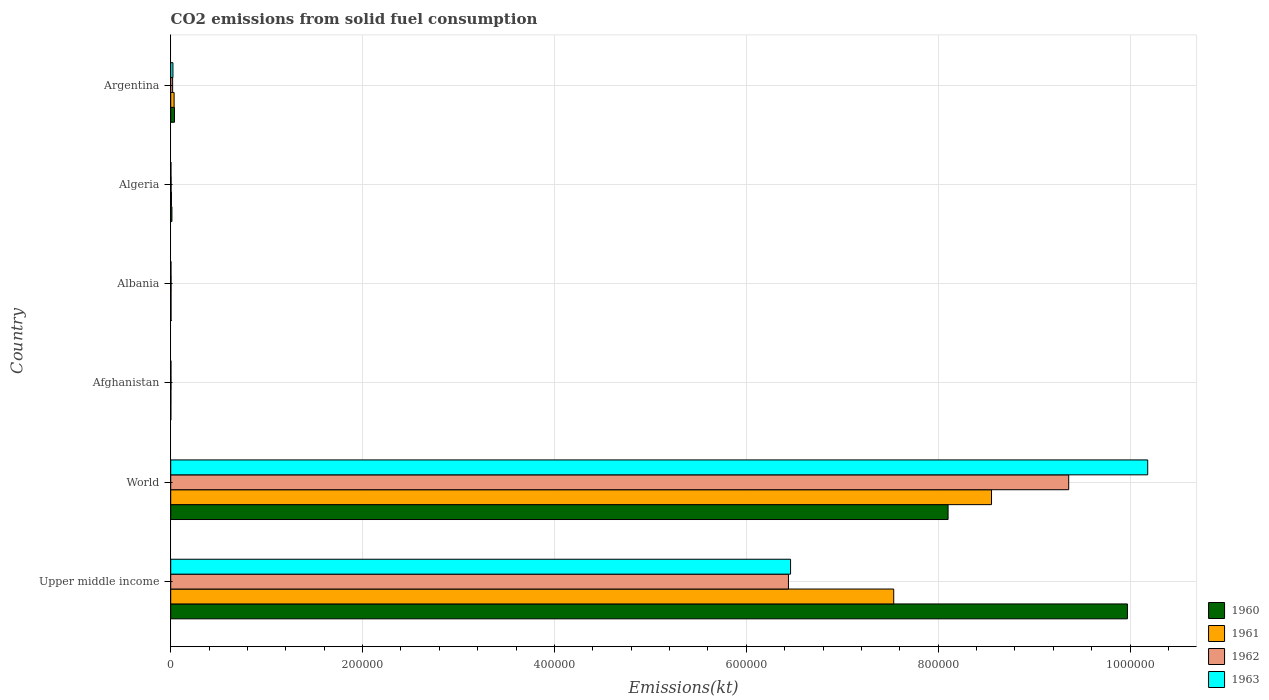How many different coloured bars are there?
Keep it short and to the point. 4. Are the number of bars per tick equal to the number of legend labels?
Keep it short and to the point. Yes. Are the number of bars on each tick of the Y-axis equal?
Provide a short and direct response. Yes. What is the label of the 5th group of bars from the top?
Offer a very short reply. World. What is the amount of CO2 emitted in 1961 in Upper middle income?
Your response must be concise. 7.54e+05. Across all countries, what is the maximum amount of CO2 emitted in 1961?
Your response must be concise. 8.56e+05. Across all countries, what is the minimum amount of CO2 emitted in 1961?
Offer a terse response. 176.02. In which country was the amount of CO2 emitted in 1963 maximum?
Keep it short and to the point. World. In which country was the amount of CO2 emitted in 1960 minimum?
Provide a short and direct response. Afghanistan. What is the total amount of CO2 emitted in 1962 in the graph?
Make the answer very short. 1.58e+06. What is the difference between the amount of CO2 emitted in 1963 in Algeria and that in World?
Keep it short and to the point. -1.02e+06. What is the difference between the amount of CO2 emitted in 1962 in Argentina and the amount of CO2 emitted in 1961 in World?
Offer a very short reply. -8.54e+05. What is the average amount of CO2 emitted in 1962 per country?
Give a very brief answer. 2.64e+05. What is the difference between the amount of CO2 emitted in 1960 and amount of CO2 emitted in 1961 in Afghanistan?
Ensure brevity in your answer.  -47.67. In how many countries, is the amount of CO2 emitted in 1962 greater than 560000 kt?
Give a very brief answer. 2. What is the ratio of the amount of CO2 emitted in 1960 in Afghanistan to that in Upper middle income?
Keep it short and to the point. 0. Is the difference between the amount of CO2 emitted in 1960 in Afghanistan and Algeria greater than the difference between the amount of CO2 emitted in 1961 in Afghanistan and Algeria?
Give a very brief answer. No. What is the difference between the highest and the second highest amount of CO2 emitted in 1963?
Give a very brief answer. 3.72e+05. What is the difference between the highest and the lowest amount of CO2 emitted in 1961?
Your answer should be very brief. 8.55e+05. Is it the case that in every country, the sum of the amount of CO2 emitted in 1962 and amount of CO2 emitted in 1963 is greater than the sum of amount of CO2 emitted in 1961 and amount of CO2 emitted in 1960?
Give a very brief answer. No. What does the 3rd bar from the top in Algeria represents?
Keep it short and to the point. 1961. Is it the case that in every country, the sum of the amount of CO2 emitted in 1963 and amount of CO2 emitted in 1960 is greater than the amount of CO2 emitted in 1962?
Offer a very short reply. Yes. How many bars are there?
Your answer should be compact. 24. Are the values on the major ticks of X-axis written in scientific E-notation?
Your answer should be very brief. No. Does the graph contain grids?
Provide a short and direct response. Yes. Where does the legend appear in the graph?
Give a very brief answer. Bottom right. How many legend labels are there?
Provide a succinct answer. 4. How are the legend labels stacked?
Offer a terse response. Vertical. What is the title of the graph?
Make the answer very short. CO2 emissions from solid fuel consumption. What is the label or title of the X-axis?
Offer a very short reply. Emissions(kt). What is the Emissions(kt) in 1960 in Upper middle income?
Ensure brevity in your answer.  9.97e+05. What is the Emissions(kt) of 1961 in Upper middle income?
Make the answer very short. 7.54e+05. What is the Emissions(kt) of 1962 in Upper middle income?
Keep it short and to the point. 6.44e+05. What is the Emissions(kt) of 1963 in Upper middle income?
Provide a succinct answer. 6.46e+05. What is the Emissions(kt) in 1960 in World?
Give a very brief answer. 8.10e+05. What is the Emissions(kt) of 1961 in World?
Provide a short and direct response. 8.56e+05. What is the Emissions(kt) of 1962 in World?
Provide a succinct answer. 9.36e+05. What is the Emissions(kt) of 1963 in World?
Provide a succinct answer. 1.02e+06. What is the Emissions(kt) in 1960 in Afghanistan?
Your answer should be compact. 128.34. What is the Emissions(kt) in 1961 in Afghanistan?
Your answer should be very brief. 176.02. What is the Emissions(kt) in 1962 in Afghanistan?
Keep it short and to the point. 297.03. What is the Emissions(kt) of 1963 in Afghanistan?
Keep it short and to the point. 264.02. What is the Emissions(kt) of 1960 in Albania?
Ensure brevity in your answer.  326.36. What is the Emissions(kt) of 1961 in Albania?
Keep it short and to the point. 322.7. What is the Emissions(kt) in 1962 in Albania?
Offer a terse response. 363.03. What is the Emissions(kt) of 1963 in Albania?
Give a very brief answer. 282.36. What is the Emissions(kt) of 1960 in Algeria?
Provide a short and direct response. 1257.78. What is the Emissions(kt) in 1961 in Algeria?
Ensure brevity in your answer.  766.4. What is the Emissions(kt) in 1962 in Algeria?
Offer a very short reply. 407.04. What is the Emissions(kt) of 1963 in Algeria?
Offer a very short reply. 253.02. What is the Emissions(kt) in 1960 in Argentina?
Your answer should be very brief. 3909.02. What is the Emissions(kt) of 1961 in Argentina?
Offer a very short reply. 3542.32. What is the Emissions(kt) in 1962 in Argentina?
Keep it short and to the point. 2009.52. What is the Emissions(kt) in 1963 in Argentina?
Your answer should be very brief. 2306.54. Across all countries, what is the maximum Emissions(kt) of 1960?
Provide a succinct answer. 9.97e+05. Across all countries, what is the maximum Emissions(kt) of 1961?
Provide a short and direct response. 8.56e+05. Across all countries, what is the maximum Emissions(kt) in 1962?
Give a very brief answer. 9.36e+05. Across all countries, what is the maximum Emissions(kt) in 1963?
Give a very brief answer. 1.02e+06. Across all countries, what is the minimum Emissions(kt) of 1960?
Offer a terse response. 128.34. Across all countries, what is the minimum Emissions(kt) of 1961?
Give a very brief answer. 176.02. Across all countries, what is the minimum Emissions(kt) in 1962?
Make the answer very short. 297.03. Across all countries, what is the minimum Emissions(kt) in 1963?
Ensure brevity in your answer.  253.02. What is the total Emissions(kt) of 1960 in the graph?
Give a very brief answer. 1.81e+06. What is the total Emissions(kt) in 1961 in the graph?
Provide a succinct answer. 1.61e+06. What is the total Emissions(kt) in 1962 in the graph?
Keep it short and to the point. 1.58e+06. What is the total Emissions(kt) in 1963 in the graph?
Make the answer very short. 1.67e+06. What is the difference between the Emissions(kt) of 1960 in Upper middle income and that in World?
Your answer should be compact. 1.87e+05. What is the difference between the Emissions(kt) of 1961 in Upper middle income and that in World?
Make the answer very short. -1.02e+05. What is the difference between the Emissions(kt) of 1962 in Upper middle income and that in World?
Offer a very short reply. -2.92e+05. What is the difference between the Emissions(kt) in 1963 in Upper middle income and that in World?
Provide a short and direct response. -3.72e+05. What is the difference between the Emissions(kt) of 1960 in Upper middle income and that in Afghanistan?
Keep it short and to the point. 9.97e+05. What is the difference between the Emissions(kt) of 1961 in Upper middle income and that in Afghanistan?
Give a very brief answer. 7.53e+05. What is the difference between the Emissions(kt) in 1962 in Upper middle income and that in Afghanistan?
Your answer should be compact. 6.44e+05. What is the difference between the Emissions(kt) of 1963 in Upper middle income and that in Afghanistan?
Offer a very short reply. 6.46e+05. What is the difference between the Emissions(kt) in 1960 in Upper middle income and that in Albania?
Your answer should be very brief. 9.97e+05. What is the difference between the Emissions(kt) of 1961 in Upper middle income and that in Albania?
Offer a very short reply. 7.53e+05. What is the difference between the Emissions(kt) in 1962 in Upper middle income and that in Albania?
Give a very brief answer. 6.44e+05. What is the difference between the Emissions(kt) in 1963 in Upper middle income and that in Albania?
Your answer should be compact. 6.46e+05. What is the difference between the Emissions(kt) in 1960 in Upper middle income and that in Algeria?
Keep it short and to the point. 9.96e+05. What is the difference between the Emissions(kt) in 1961 in Upper middle income and that in Algeria?
Make the answer very short. 7.53e+05. What is the difference between the Emissions(kt) of 1962 in Upper middle income and that in Algeria?
Provide a succinct answer. 6.44e+05. What is the difference between the Emissions(kt) in 1963 in Upper middle income and that in Algeria?
Your answer should be compact. 6.46e+05. What is the difference between the Emissions(kt) of 1960 in Upper middle income and that in Argentina?
Your answer should be very brief. 9.93e+05. What is the difference between the Emissions(kt) in 1961 in Upper middle income and that in Argentina?
Make the answer very short. 7.50e+05. What is the difference between the Emissions(kt) of 1962 in Upper middle income and that in Argentina?
Your answer should be very brief. 6.42e+05. What is the difference between the Emissions(kt) in 1963 in Upper middle income and that in Argentina?
Make the answer very short. 6.44e+05. What is the difference between the Emissions(kt) in 1960 in World and that in Afghanistan?
Offer a very short reply. 8.10e+05. What is the difference between the Emissions(kt) of 1961 in World and that in Afghanistan?
Your response must be concise. 8.55e+05. What is the difference between the Emissions(kt) in 1962 in World and that in Afghanistan?
Your answer should be compact. 9.36e+05. What is the difference between the Emissions(kt) of 1963 in World and that in Afghanistan?
Provide a short and direct response. 1.02e+06. What is the difference between the Emissions(kt) in 1960 in World and that in Albania?
Keep it short and to the point. 8.10e+05. What is the difference between the Emissions(kt) of 1961 in World and that in Albania?
Keep it short and to the point. 8.55e+05. What is the difference between the Emissions(kt) in 1962 in World and that in Albania?
Your answer should be compact. 9.36e+05. What is the difference between the Emissions(kt) in 1963 in World and that in Albania?
Keep it short and to the point. 1.02e+06. What is the difference between the Emissions(kt) in 1960 in World and that in Algeria?
Provide a short and direct response. 8.09e+05. What is the difference between the Emissions(kt) of 1961 in World and that in Algeria?
Your answer should be compact. 8.55e+05. What is the difference between the Emissions(kt) of 1962 in World and that in Algeria?
Your answer should be compact. 9.36e+05. What is the difference between the Emissions(kt) of 1963 in World and that in Algeria?
Provide a succinct answer. 1.02e+06. What is the difference between the Emissions(kt) of 1960 in World and that in Argentina?
Provide a short and direct response. 8.06e+05. What is the difference between the Emissions(kt) in 1961 in World and that in Argentina?
Provide a short and direct response. 8.52e+05. What is the difference between the Emissions(kt) of 1962 in World and that in Argentina?
Your answer should be compact. 9.34e+05. What is the difference between the Emissions(kt) in 1963 in World and that in Argentina?
Keep it short and to the point. 1.02e+06. What is the difference between the Emissions(kt) in 1960 in Afghanistan and that in Albania?
Ensure brevity in your answer.  -198.02. What is the difference between the Emissions(kt) of 1961 in Afghanistan and that in Albania?
Offer a terse response. -146.68. What is the difference between the Emissions(kt) of 1962 in Afghanistan and that in Albania?
Offer a very short reply. -66.01. What is the difference between the Emissions(kt) in 1963 in Afghanistan and that in Albania?
Provide a short and direct response. -18.34. What is the difference between the Emissions(kt) in 1960 in Afghanistan and that in Algeria?
Provide a short and direct response. -1129.44. What is the difference between the Emissions(kt) of 1961 in Afghanistan and that in Algeria?
Make the answer very short. -590.39. What is the difference between the Emissions(kt) in 1962 in Afghanistan and that in Algeria?
Your answer should be very brief. -110.01. What is the difference between the Emissions(kt) of 1963 in Afghanistan and that in Algeria?
Make the answer very short. 11. What is the difference between the Emissions(kt) of 1960 in Afghanistan and that in Argentina?
Give a very brief answer. -3780.68. What is the difference between the Emissions(kt) in 1961 in Afghanistan and that in Argentina?
Make the answer very short. -3366.31. What is the difference between the Emissions(kt) in 1962 in Afghanistan and that in Argentina?
Provide a succinct answer. -1712.49. What is the difference between the Emissions(kt) of 1963 in Afghanistan and that in Argentina?
Provide a succinct answer. -2042.52. What is the difference between the Emissions(kt) of 1960 in Albania and that in Algeria?
Your answer should be very brief. -931.42. What is the difference between the Emissions(kt) in 1961 in Albania and that in Algeria?
Your answer should be very brief. -443.71. What is the difference between the Emissions(kt) of 1962 in Albania and that in Algeria?
Ensure brevity in your answer.  -44. What is the difference between the Emissions(kt) of 1963 in Albania and that in Algeria?
Offer a terse response. 29.34. What is the difference between the Emissions(kt) in 1960 in Albania and that in Argentina?
Give a very brief answer. -3582.66. What is the difference between the Emissions(kt) in 1961 in Albania and that in Argentina?
Make the answer very short. -3219.63. What is the difference between the Emissions(kt) of 1962 in Albania and that in Argentina?
Keep it short and to the point. -1646.48. What is the difference between the Emissions(kt) of 1963 in Albania and that in Argentina?
Provide a succinct answer. -2024.18. What is the difference between the Emissions(kt) in 1960 in Algeria and that in Argentina?
Ensure brevity in your answer.  -2651.24. What is the difference between the Emissions(kt) in 1961 in Algeria and that in Argentina?
Offer a terse response. -2775.92. What is the difference between the Emissions(kt) of 1962 in Algeria and that in Argentina?
Give a very brief answer. -1602.48. What is the difference between the Emissions(kt) in 1963 in Algeria and that in Argentina?
Your answer should be compact. -2053.52. What is the difference between the Emissions(kt) of 1960 in Upper middle income and the Emissions(kt) of 1961 in World?
Offer a very short reply. 1.42e+05. What is the difference between the Emissions(kt) in 1960 in Upper middle income and the Emissions(kt) in 1962 in World?
Offer a very short reply. 6.12e+04. What is the difference between the Emissions(kt) of 1960 in Upper middle income and the Emissions(kt) of 1963 in World?
Ensure brevity in your answer.  -2.12e+04. What is the difference between the Emissions(kt) of 1961 in Upper middle income and the Emissions(kt) of 1962 in World?
Keep it short and to the point. -1.82e+05. What is the difference between the Emissions(kt) in 1961 in Upper middle income and the Emissions(kt) in 1963 in World?
Your response must be concise. -2.65e+05. What is the difference between the Emissions(kt) of 1962 in Upper middle income and the Emissions(kt) of 1963 in World?
Ensure brevity in your answer.  -3.74e+05. What is the difference between the Emissions(kt) of 1960 in Upper middle income and the Emissions(kt) of 1961 in Afghanistan?
Your response must be concise. 9.97e+05. What is the difference between the Emissions(kt) of 1960 in Upper middle income and the Emissions(kt) of 1962 in Afghanistan?
Your response must be concise. 9.97e+05. What is the difference between the Emissions(kt) of 1960 in Upper middle income and the Emissions(kt) of 1963 in Afghanistan?
Provide a succinct answer. 9.97e+05. What is the difference between the Emissions(kt) in 1961 in Upper middle income and the Emissions(kt) in 1962 in Afghanistan?
Ensure brevity in your answer.  7.53e+05. What is the difference between the Emissions(kt) of 1961 in Upper middle income and the Emissions(kt) of 1963 in Afghanistan?
Your response must be concise. 7.53e+05. What is the difference between the Emissions(kt) in 1962 in Upper middle income and the Emissions(kt) in 1963 in Afghanistan?
Offer a terse response. 6.44e+05. What is the difference between the Emissions(kt) in 1960 in Upper middle income and the Emissions(kt) in 1961 in Albania?
Your answer should be very brief. 9.97e+05. What is the difference between the Emissions(kt) in 1960 in Upper middle income and the Emissions(kt) in 1962 in Albania?
Give a very brief answer. 9.97e+05. What is the difference between the Emissions(kt) in 1960 in Upper middle income and the Emissions(kt) in 1963 in Albania?
Give a very brief answer. 9.97e+05. What is the difference between the Emissions(kt) in 1961 in Upper middle income and the Emissions(kt) in 1962 in Albania?
Your answer should be very brief. 7.53e+05. What is the difference between the Emissions(kt) in 1961 in Upper middle income and the Emissions(kt) in 1963 in Albania?
Ensure brevity in your answer.  7.53e+05. What is the difference between the Emissions(kt) of 1962 in Upper middle income and the Emissions(kt) of 1963 in Albania?
Offer a very short reply. 6.44e+05. What is the difference between the Emissions(kt) of 1960 in Upper middle income and the Emissions(kt) of 1961 in Algeria?
Offer a terse response. 9.97e+05. What is the difference between the Emissions(kt) of 1960 in Upper middle income and the Emissions(kt) of 1962 in Algeria?
Offer a terse response. 9.97e+05. What is the difference between the Emissions(kt) of 1960 in Upper middle income and the Emissions(kt) of 1963 in Algeria?
Offer a very short reply. 9.97e+05. What is the difference between the Emissions(kt) in 1961 in Upper middle income and the Emissions(kt) in 1962 in Algeria?
Keep it short and to the point. 7.53e+05. What is the difference between the Emissions(kt) in 1961 in Upper middle income and the Emissions(kt) in 1963 in Algeria?
Give a very brief answer. 7.53e+05. What is the difference between the Emissions(kt) in 1962 in Upper middle income and the Emissions(kt) in 1963 in Algeria?
Keep it short and to the point. 6.44e+05. What is the difference between the Emissions(kt) in 1960 in Upper middle income and the Emissions(kt) in 1961 in Argentina?
Make the answer very short. 9.94e+05. What is the difference between the Emissions(kt) of 1960 in Upper middle income and the Emissions(kt) of 1962 in Argentina?
Give a very brief answer. 9.95e+05. What is the difference between the Emissions(kt) of 1960 in Upper middle income and the Emissions(kt) of 1963 in Argentina?
Ensure brevity in your answer.  9.95e+05. What is the difference between the Emissions(kt) in 1961 in Upper middle income and the Emissions(kt) in 1962 in Argentina?
Keep it short and to the point. 7.52e+05. What is the difference between the Emissions(kt) in 1961 in Upper middle income and the Emissions(kt) in 1963 in Argentina?
Ensure brevity in your answer.  7.51e+05. What is the difference between the Emissions(kt) in 1962 in Upper middle income and the Emissions(kt) in 1963 in Argentina?
Provide a short and direct response. 6.42e+05. What is the difference between the Emissions(kt) of 1960 in World and the Emissions(kt) of 1961 in Afghanistan?
Ensure brevity in your answer.  8.10e+05. What is the difference between the Emissions(kt) of 1960 in World and the Emissions(kt) of 1962 in Afghanistan?
Give a very brief answer. 8.10e+05. What is the difference between the Emissions(kt) in 1960 in World and the Emissions(kt) in 1963 in Afghanistan?
Ensure brevity in your answer.  8.10e+05. What is the difference between the Emissions(kt) in 1961 in World and the Emissions(kt) in 1962 in Afghanistan?
Offer a very short reply. 8.55e+05. What is the difference between the Emissions(kt) in 1961 in World and the Emissions(kt) in 1963 in Afghanistan?
Your answer should be very brief. 8.55e+05. What is the difference between the Emissions(kt) in 1962 in World and the Emissions(kt) in 1963 in Afghanistan?
Your answer should be very brief. 9.36e+05. What is the difference between the Emissions(kt) in 1960 in World and the Emissions(kt) in 1961 in Albania?
Ensure brevity in your answer.  8.10e+05. What is the difference between the Emissions(kt) of 1960 in World and the Emissions(kt) of 1962 in Albania?
Provide a short and direct response. 8.10e+05. What is the difference between the Emissions(kt) of 1960 in World and the Emissions(kt) of 1963 in Albania?
Provide a succinct answer. 8.10e+05. What is the difference between the Emissions(kt) of 1961 in World and the Emissions(kt) of 1962 in Albania?
Give a very brief answer. 8.55e+05. What is the difference between the Emissions(kt) of 1961 in World and the Emissions(kt) of 1963 in Albania?
Ensure brevity in your answer.  8.55e+05. What is the difference between the Emissions(kt) of 1962 in World and the Emissions(kt) of 1963 in Albania?
Ensure brevity in your answer.  9.36e+05. What is the difference between the Emissions(kt) in 1960 in World and the Emissions(kt) in 1961 in Algeria?
Give a very brief answer. 8.10e+05. What is the difference between the Emissions(kt) in 1960 in World and the Emissions(kt) in 1962 in Algeria?
Keep it short and to the point. 8.10e+05. What is the difference between the Emissions(kt) in 1960 in World and the Emissions(kt) in 1963 in Algeria?
Your answer should be very brief. 8.10e+05. What is the difference between the Emissions(kt) of 1961 in World and the Emissions(kt) of 1962 in Algeria?
Your response must be concise. 8.55e+05. What is the difference between the Emissions(kt) in 1961 in World and the Emissions(kt) in 1963 in Algeria?
Give a very brief answer. 8.55e+05. What is the difference between the Emissions(kt) of 1962 in World and the Emissions(kt) of 1963 in Algeria?
Ensure brevity in your answer.  9.36e+05. What is the difference between the Emissions(kt) of 1960 in World and the Emissions(kt) of 1961 in Argentina?
Offer a terse response. 8.07e+05. What is the difference between the Emissions(kt) in 1960 in World and the Emissions(kt) in 1962 in Argentina?
Offer a very short reply. 8.08e+05. What is the difference between the Emissions(kt) in 1960 in World and the Emissions(kt) in 1963 in Argentina?
Your answer should be compact. 8.08e+05. What is the difference between the Emissions(kt) of 1961 in World and the Emissions(kt) of 1962 in Argentina?
Provide a short and direct response. 8.54e+05. What is the difference between the Emissions(kt) of 1961 in World and the Emissions(kt) of 1963 in Argentina?
Your response must be concise. 8.53e+05. What is the difference between the Emissions(kt) of 1962 in World and the Emissions(kt) of 1963 in Argentina?
Give a very brief answer. 9.34e+05. What is the difference between the Emissions(kt) in 1960 in Afghanistan and the Emissions(kt) in 1961 in Albania?
Ensure brevity in your answer.  -194.35. What is the difference between the Emissions(kt) in 1960 in Afghanistan and the Emissions(kt) in 1962 in Albania?
Make the answer very short. -234.69. What is the difference between the Emissions(kt) of 1960 in Afghanistan and the Emissions(kt) of 1963 in Albania?
Offer a terse response. -154.01. What is the difference between the Emissions(kt) of 1961 in Afghanistan and the Emissions(kt) of 1962 in Albania?
Keep it short and to the point. -187.02. What is the difference between the Emissions(kt) in 1961 in Afghanistan and the Emissions(kt) in 1963 in Albania?
Your answer should be very brief. -106.34. What is the difference between the Emissions(kt) of 1962 in Afghanistan and the Emissions(kt) of 1963 in Albania?
Offer a terse response. 14.67. What is the difference between the Emissions(kt) of 1960 in Afghanistan and the Emissions(kt) of 1961 in Algeria?
Your answer should be very brief. -638.06. What is the difference between the Emissions(kt) of 1960 in Afghanistan and the Emissions(kt) of 1962 in Algeria?
Your answer should be very brief. -278.69. What is the difference between the Emissions(kt) of 1960 in Afghanistan and the Emissions(kt) of 1963 in Algeria?
Offer a very short reply. -124.68. What is the difference between the Emissions(kt) of 1961 in Afghanistan and the Emissions(kt) of 1962 in Algeria?
Ensure brevity in your answer.  -231.02. What is the difference between the Emissions(kt) in 1961 in Afghanistan and the Emissions(kt) in 1963 in Algeria?
Your answer should be compact. -77.01. What is the difference between the Emissions(kt) in 1962 in Afghanistan and the Emissions(kt) in 1963 in Algeria?
Keep it short and to the point. 44. What is the difference between the Emissions(kt) in 1960 in Afghanistan and the Emissions(kt) in 1961 in Argentina?
Your answer should be compact. -3413.98. What is the difference between the Emissions(kt) of 1960 in Afghanistan and the Emissions(kt) of 1962 in Argentina?
Provide a succinct answer. -1881.17. What is the difference between the Emissions(kt) of 1960 in Afghanistan and the Emissions(kt) of 1963 in Argentina?
Offer a terse response. -2178.2. What is the difference between the Emissions(kt) in 1961 in Afghanistan and the Emissions(kt) in 1962 in Argentina?
Your answer should be very brief. -1833.5. What is the difference between the Emissions(kt) in 1961 in Afghanistan and the Emissions(kt) in 1963 in Argentina?
Your response must be concise. -2130.53. What is the difference between the Emissions(kt) in 1962 in Afghanistan and the Emissions(kt) in 1963 in Argentina?
Keep it short and to the point. -2009.52. What is the difference between the Emissions(kt) of 1960 in Albania and the Emissions(kt) of 1961 in Algeria?
Offer a very short reply. -440.04. What is the difference between the Emissions(kt) in 1960 in Albania and the Emissions(kt) in 1962 in Algeria?
Your answer should be very brief. -80.67. What is the difference between the Emissions(kt) of 1960 in Albania and the Emissions(kt) of 1963 in Algeria?
Offer a very short reply. 73.34. What is the difference between the Emissions(kt) of 1961 in Albania and the Emissions(kt) of 1962 in Algeria?
Your response must be concise. -84.34. What is the difference between the Emissions(kt) of 1961 in Albania and the Emissions(kt) of 1963 in Algeria?
Ensure brevity in your answer.  69.67. What is the difference between the Emissions(kt) in 1962 in Albania and the Emissions(kt) in 1963 in Algeria?
Offer a very short reply. 110.01. What is the difference between the Emissions(kt) in 1960 in Albania and the Emissions(kt) in 1961 in Argentina?
Make the answer very short. -3215.96. What is the difference between the Emissions(kt) in 1960 in Albania and the Emissions(kt) in 1962 in Argentina?
Ensure brevity in your answer.  -1683.15. What is the difference between the Emissions(kt) of 1960 in Albania and the Emissions(kt) of 1963 in Argentina?
Offer a terse response. -1980.18. What is the difference between the Emissions(kt) of 1961 in Albania and the Emissions(kt) of 1962 in Argentina?
Provide a succinct answer. -1686.82. What is the difference between the Emissions(kt) of 1961 in Albania and the Emissions(kt) of 1963 in Argentina?
Keep it short and to the point. -1983.85. What is the difference between the Emissions(kt) in 1962 in Albania and the Emissions(kt) in 1963 in Argentina?
Your answer should be compact. -1943.51. What is the difference between the Emissions(kt) in 1960 in Algeria and the Emissions(kt) in 1961 in Argentina?
Provide a short and direct response. -2284.54. What is the difference between the Emissions(kt) in 1960 in Algeria and the Emissions(kt) in 1962 in Argentina?
Keep it short and to the point. -751.74. What is the difference between the Emissions(kt) of 1960 in Algeria and the Emissions(kt) of 1963 in Argentina?
Provide a succinct answer. -1048.76. What is the difference between the Emissions(kt) in 1961 in Algeria and the Emissions(kt) in 1962 in Argentina?
Offer a very short reply. -1243.11. What is the difference between the Emissions(kt) of 1961 in Algeria and the Emissions(kt) of 1963 in Argentina?
Ensure brevity in your answer.  -1540.14. What is the difference between the Emissions(kt) of 1962 in Algeria and the Emissions(kt) of 1963 in Argentina?
Ensure brevity in your answer.  -1899.51. What is the average Emissions(kt) in 1960 per country?
Give a very brief answer. 3.02e+05. What is the average Emissions(kt) of 1961 per country?
Your answer should be compact. 2.69e+05. What is the average Emissions(kt) in 1962 per country?
Provide a short and direct response. 2.64e+05. What is the average Emissions(kt) in 1963 per country?
Your response must be concise. 2.78e+05. What is the difference between the Emissions(kt) in 1960 and Emissions(kt) in 1961 in Upper middle income?
Provide a short and direct response. 2.44e+05. What is the difference between the Emissions(kt) of 1960 and Emissions(kt) of 1962 in Upper middle income?
Provide a succinct answer. 3.53e+05. What is the difference between the Emissions(kt) in 1960 and Emissions(kt) in 1963 in Upper middle income?
Make the answer very short. 3.51e+05. What is the difference between the Emissions(kt) in 1961 and Emissions(kt) in 1962 in Upper middle income?
Provide a short and direct response. 1.10e+05. What is the difference between the Emissions(kt) of 1961 and Emissions(kt) of 1963 in Upper middle income?
Offer a terse response. 1.08e+05. What is the difference between the Emissions(kt) in 1962 and Emissions(kt) in 1963 in Upper middle income?
Offer a terse response. -2192.22. What is the difference between the Emissions(kt) of 1960 and Emissions(kt) of 1961 in World?
Offer a terse response. -4.53e+04. What is the difference between the Emissions(kt) in 1960 and Emissions(kt) in 1962 in World?
Your response must be concise. -1.26e+05. What is the difference between the Emissions(kt) of 1960 and Emissions(kt) of 1963 in World?
Offer a terse response. -2.08e+05. What is the difference between the Emissions(kt) in 1961 and Emissions(kt) in 1962 in World?
Your answer should be compact. -8.05e+04. What is the difference between the Emissions(kt) in 1961 and Emissions(kt) in 1963 in World?
Give a very brief answer. -1.63e+05. What is the difference between the Emissions(kt) in 1962 and Emissions(kt) in 1963 in World?
Offer a very short reply. -8.24e+04. What is the difference between the Emissions(kt) in 1960 and Emissions(kt) in 1961 in Afghanistan?
Your answer should be compact. -47.67. What is the difference between the Emissions(kt) in 1960 and Emissions(kt) in 1962 in Afghanistan?
Keep it short and to the point. -168.68. What is the difference between the Emissions(kt) of 1960 and Emissions(kt) of 1963 in Afghanistan?
Your answer should be very brief. -135.68. What is the difference between the Emissions(kt) in 1961 and Emissions(kt) in 1962 in Afghanistan?
Ensure brevity in your answer.  -121.01. What is the difference between the Emissions(kt) in 1961 and Emissions(kt) in 1963 in Afghanistan?
Your answer should be very brief. -88.01. What is the difference between the Emissions(kt) in 1962 and Emissions(kt) in 1963 in Afghanistan?
Keep it short and to the point. 33. What is the difference between the Emissions(kt) of 1960 and Emissions(kt) of 1961 in Albania?
Ensure brevity in your answer.  3.67. What is the difference between the Emissions(kt) in 1960 and Emissions(kt) in 1962 in Albania?
Make the answer very short. -36.67. What is the difference between the Emissions(kt) of 1960 and Emissions(kt) of 1963 in Albania?
Your answer should be very brief. 44. What is the difference between the Emissions(kt) in 1961 and Emissions(kt) in 1962 in Albania?
Your response must be concise. -40.34. What is the difference between the Emissions(kt) in 1961 and Emissions(kt) in 1963 in Albania?
Offer a terse response. 40.34. What is the difference between the Emissions(kt) in 1962 and Emissions(kt) in 1963 in Albania?
Your response must be concise. 80.67. What is the difference between the Emissions(kt) in 1960 and Emissions(kt) in 1961 in Algeria?
Ensure brevity in your answer.  491.38. What is the difference between the Emissions(kt) of 1960 and Emissions(kt) of 1962 in Algeria?
Make the answer very short. 850.74. What is the difference between the Emissions(kt) in 1960 and Emissions(kt) in 1963 in Algeria?
Give a very brief answer. 1004.76. What is the difference between the Emissions(kt) of 1961 and Emissions(kt) of 1962 in Algeria?
Your answer should be very brief. 359.37. What is the difference between the Emissions(kt) of 1961 and Emissions(kt) of 1963 in Algeria?
Provide a succinct answer. 513.38. What is the difference between the Emissions(kt) in 1962 and Emissions(kt) in 1963 in Algeria?
Offer a terse response. 154.01. What is the difference between the Emissions(kt) in 1960 and Emissions(kt) in 1961 in Argentina?
Your answer should be compact. 366.7. What is the difference between the Emissions(kt) of 1960 and Emissions(kt) of 1962 in Argentina?
Offer a very short reply. 1899.51. What is the difference between the Emissions(kt) in 1960 and Emissions(kt) in 1963 in Argentina?
Provide a succinct answer. 1602.48. What is the difference between the Emissions(kt) of 1961 and Emissions(kt) of 1962 in Argentina?
Make the answer very short. 1532.81. What is the difference between the Emissions(kt) in 1961 and Emissions(kt) in 1963 in Argentina?
Your response must be concise. 1235.78. What is the difference between the Emissions(kt) of 1962 and Emissions(kt) of 1963 in Argentina?
Offer a terse response. -297.03. What is the ratio of the Emissions(kt) in 1960 in Upper middle income to that in World?
Keep it short and to the point. 1.23. What is the ratio of the Emissions(kt) of 1961 in Upper middle income to that in World?
Offer a terse response. 0.88. What is the ratio of the Emissions(kt) of 1962 in Upper middle income to that in World?
Your response must be concise. 0.69. What is the ratio of the Emissions(kt) in 1963 in Upper middle income to that in World?
Ensure brevity in your answer.  0.63. What is the ratio of the Emissions(kt) in 1960 in Upper middle income to that in Afghanistan?
Give a very brief answer. 7770.2. What is the ratio of the Emissions(kt) in 1961 in Upper middle income to that in Afghanistan?
Offer a very short reply. 4281.81. What is the ratio of the Emissions(kt) in 1962 in Upper middle income to that in Afghanistan?
Your answer should be compact. 2167.93. What is the ratio of the Emissions(kt) of 1963 in Upper middle income to that in Afghanistan?
Make the answer very short. 2447.22. What is the ratio of the Emissions(kt) of 1960 in Upper middle income to that in Albania?
Make the answer very short. 3055.7. What is the ratio of the Emissions(kt) of 1961 in Upper middle income to that in Albania?
Provide a short and direct response. 2335.53. What is the ratio of the Emissions(kt) of 1962 in Upper middle income to that in Albania?
Your answer should be compact. 1773.76. What is the ratio of the Emissions(kt) in 1963 in Upper middle income to that in Albania?
Keep it short and to the point. 2288.31. What is the ratio of the Emissions(kt) of 1960 in Upper middle income to that in Algeria?
Offer a terse response. 792.88. What is the ratio of the Emissions(kt) of 1961 in Upper middle income to that in Algeria?
Make the answer very short. 983.38. What is the ratio of the Emissions(kt) of 1962 in Upper middle income to that in Algeria?
Ensure brevity in your answer.  1582. What is the ratio of the Emissions(kt) of 1963 in Upper middle income to that in Algeria?
Ensure brevity in your answer.  2553.62. What is the ratio of the Emissions(kt) of 1960 in Upper middle income to that in Argentina?
Offer a terse response. 255.12. What is the ratio of the Emissions(kt) in 1961 in Upper middle income to that in Argentina?
Provide a succinct answer. 212.76. What is the ratio of the Emissions(kt) in 1962 in Upper middle income to that in Argentina?
Keep it short and to the point. 320.44. What is the ratio of the Emissions(kt) of 1963 in Upper middle income to that in Argentina?
Ensure brevity in your answer.  280.13. What is the ratio of the Emissions(kt) of 1960 in World to that in Afghanistan?
Offer a very short reply. 6313.69. What is the ratio of the Emissions(kt) in 1961 in World to that in Afghanistan?
Offer a terse response. 4860.98. What is the ratio of the Emissions(kt) of 1962 in World to that in Afghanistan?
Make the answer very short. 3151.44. What is the ratio of the Emissions(kt) of 1963 in World to that in Afghanistan?
Your answer should be compact. 3857.29. What is the ratio of the Emissions(kt) in 1960 in World to that in Albania?
Your answer should be compact. 2482.91. What is the ratio of the Emissions(kt) in 1961 in World to that in Albania?
Your answer should be very brief. 2651.44. What is the ratio of the Emissions(kt) in 1962 in World to that in Albania?
Make the answer very short. 2578.45. What is the ratio of the Emissions(kt) in 1963 in World to that in Albania?
Make the answer very short. 3606.82. What is the ratio of the Emissions(kt) of 1960 in World to that in Algeria?
Your answer should be very brief. 644.25. What is the ratio of the Emissions(kt) of 1961 in World to that in Algeria?
Offer a very short reply. 1116.4. What is the ratio of the Emissions(kt) in 1962 in World to that in Algeria?
Your answer should be very brief. 2299.7. What is the ratio of the Emissions(kt) in 1963 in World to that in Algeria?
Your response must be concise. 4025. What is the ratio of the Emissions(kt) of 1960 in World to that in Argentina?
Give a very brief answer. 207.3. What is the ratio of the Emissions(kt) in 1961 in World to that in Argentina?
Your answer should be very brief. 241.54. What is the ratio of the Emissions(kt) in 1962 in World to that in Argentina?
Provide a succinct answer. 465.82. What is the ratio of the Emissions(kt) in 1963 in World to that in Argentina?
Your response must be concise. 441.53. What is the ratio of the Emissions(kt) of 1960 in Afghanistan to that in Albania?
Keep it short and to the point. 0.39. What is the ratio of the Emissions(kt) in 1961 in Afghanistan to that in Albania?
Provide a short and direct response. 0.55. What is the ratio of the Emissions(kt) in 1962 in Afghanistan to that in Albania?
Your answer should be compact. 0.82. What is the ratio of the Emissions(kt) of 1963 in Afghanistan to that in Albania?
Your answer should be very brief. 0.94. What is the ratio of the Emissions(kt) of 1960 in Afghanistan to that in Algeria?
Offer a terse response. 0.1. What is the ratio of the Emissions(kt) in 1961 in Afghanistan to that in Algeria?
Offer a very short reply. 0.23. What is the ratio of the Emissions(kt) in 1962 in Afghanistan to that in Algeria?
Give a very brief answer. 0.73. What is the ratio of the Emissions(kt) of 1963 in Afghanistan to that in Algeria?
Your answer should be very brief. 1.04. What is the ratio of the Emissions(kt) in 1960 in Afghanistan to that in Argentina?
Keep it short and to the point. 0.03. What is the ratio of the Emissions(kt) of 1961 in Afghanistan to that in Argentina?
Keep it short and to the point. 0.05. What is the ratio of the Emissions(kt) of 1962 in Afghanistan to that in Argentina?
Your answer should be compact. 0.15. What is the ratio of the Emissions(kt) of 1963 in Afghanistan to that in Argentina?
Your answer should be very brief. 0.11. What is the ratio of the Emissions(kt) of 1960 in Albania to that in Algeria?
Give a very brief answer. 0.26. What is the ratio of the Emissions(kt) in 1961 in Albania to that in Algeria?
Your response must be concise. 0.42. What is the ratio of the Emissions(kt) in 1962 in Albania to that in Algeria?
Your answer should be very brief. 0.89. What is the ratio of the Emissions(kt) of 1963 in Albania to that in Algeria?
Your response must be concise. 1.12. What is the ratio of the Emissions(kt) of 1960 in Albania to that in Argentina?
Keep it short and to the point. 0.08. What is the ratio of the Emissions(kt) in 1961 in Albania to that in Argentina?
Keep it short and to the point. 0.09. What is the ratio of the Emissions(kt) in 1962 in Albania to that in Argentina?
Your response must be concise. 0.18. What is the ratio of the Emissions(kt) in 1963 in Albania to that in Argentina?
Ensure brevity in your answer.  0.12. What is the ratio of the Emissions(kt) in 1960 in Algeria to that in Argentina?
Keep it short and to the point. 0.32. What is the ratio of the Emissions(kt) of 1961 in Algeria to that in Argentina?
Make the answer very short. 0.22. What is the ratio of the Emissions(kt) in 1962 in Algeria to that in Argentina?
Provide a short and direct response. 0.2. What is the ratio of the Emissions(kt) in 1963 in Algeria to that in Argentina?
Your response must be concise. 0.11. What is the difference between the highest and the second highest Emissions(kt) in 1960?
Give a very brief answer. 1.87e+05. What is the difference between the highest and the second highest Emissions(kt) in 1961?
Give a very brief answer. 1.02e+05. What is the difference between the highest and the second highest Emissions(kt) of 1962?
Give a very brief answer. 2.92e+05. What is the difference between the highest and the second highest Emissions(kt) in 1963?
Your answer should be very brief. 3.72e+05. What is the difference between the highest and the lowest Emissions(kt) in 1960?
Give a very brief answer. 9.97e+05. What is the difference between the highest and the lowest Emissions(kt) in 1961?
Your answer should be very brief. 8.55e+05. What is the difference between the highest and the lowest Emissions(kt) in 1962?
Offer a very short reply. 9.36e+05. What is the difference between the highest and the lowest Emissions(kt) in 1963?
Your response must be concise. 1.02e+06. 